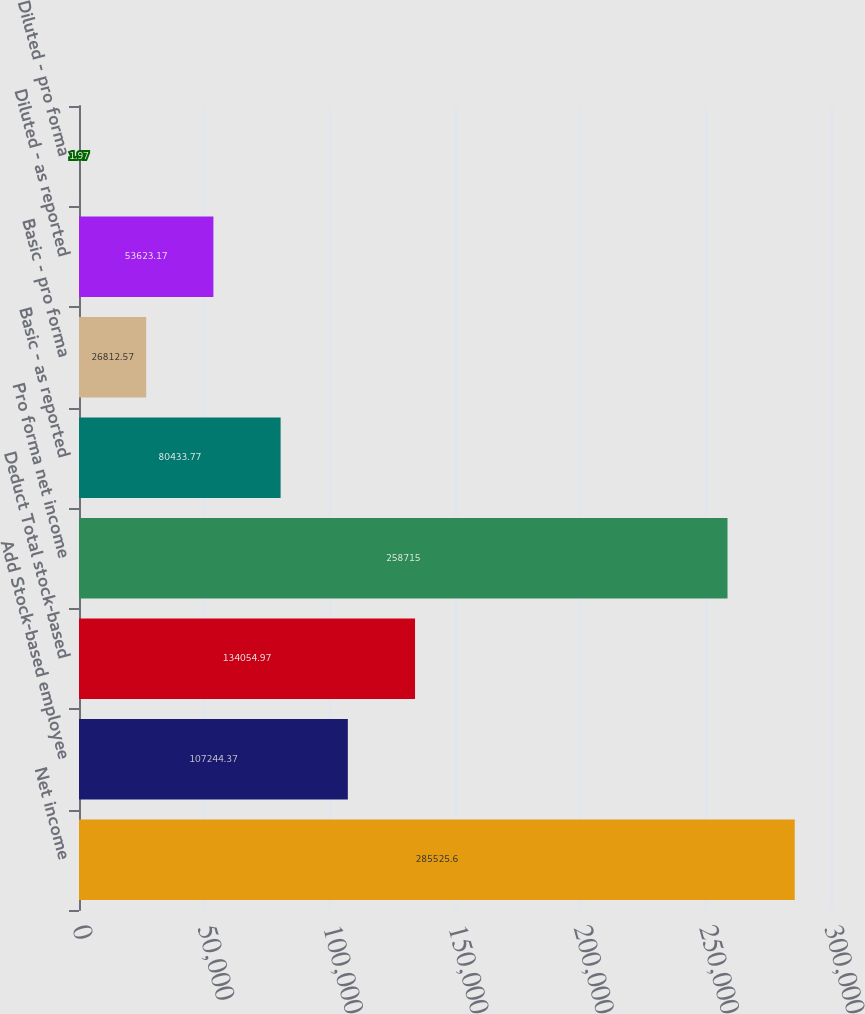<chart> <loc_0><loc_0><loc_500><loc_500><bar_chart><fcel>Net income<fcel>Add Stock-based employee<fcel>Deduct Total stock-based<fcel>Pro forma net income<fcel>Basic - as reported<fcel>Basic - pro forma<fcel>Diluted - as reported<fcel>Diluted - pro forma<nl><fcel>285526<fcel>107244<fcel>134055<fcel>258715<fcel>80433.8<fcel>26812.6<fcel>53623.2<fcel>1.97<nl></chart> 